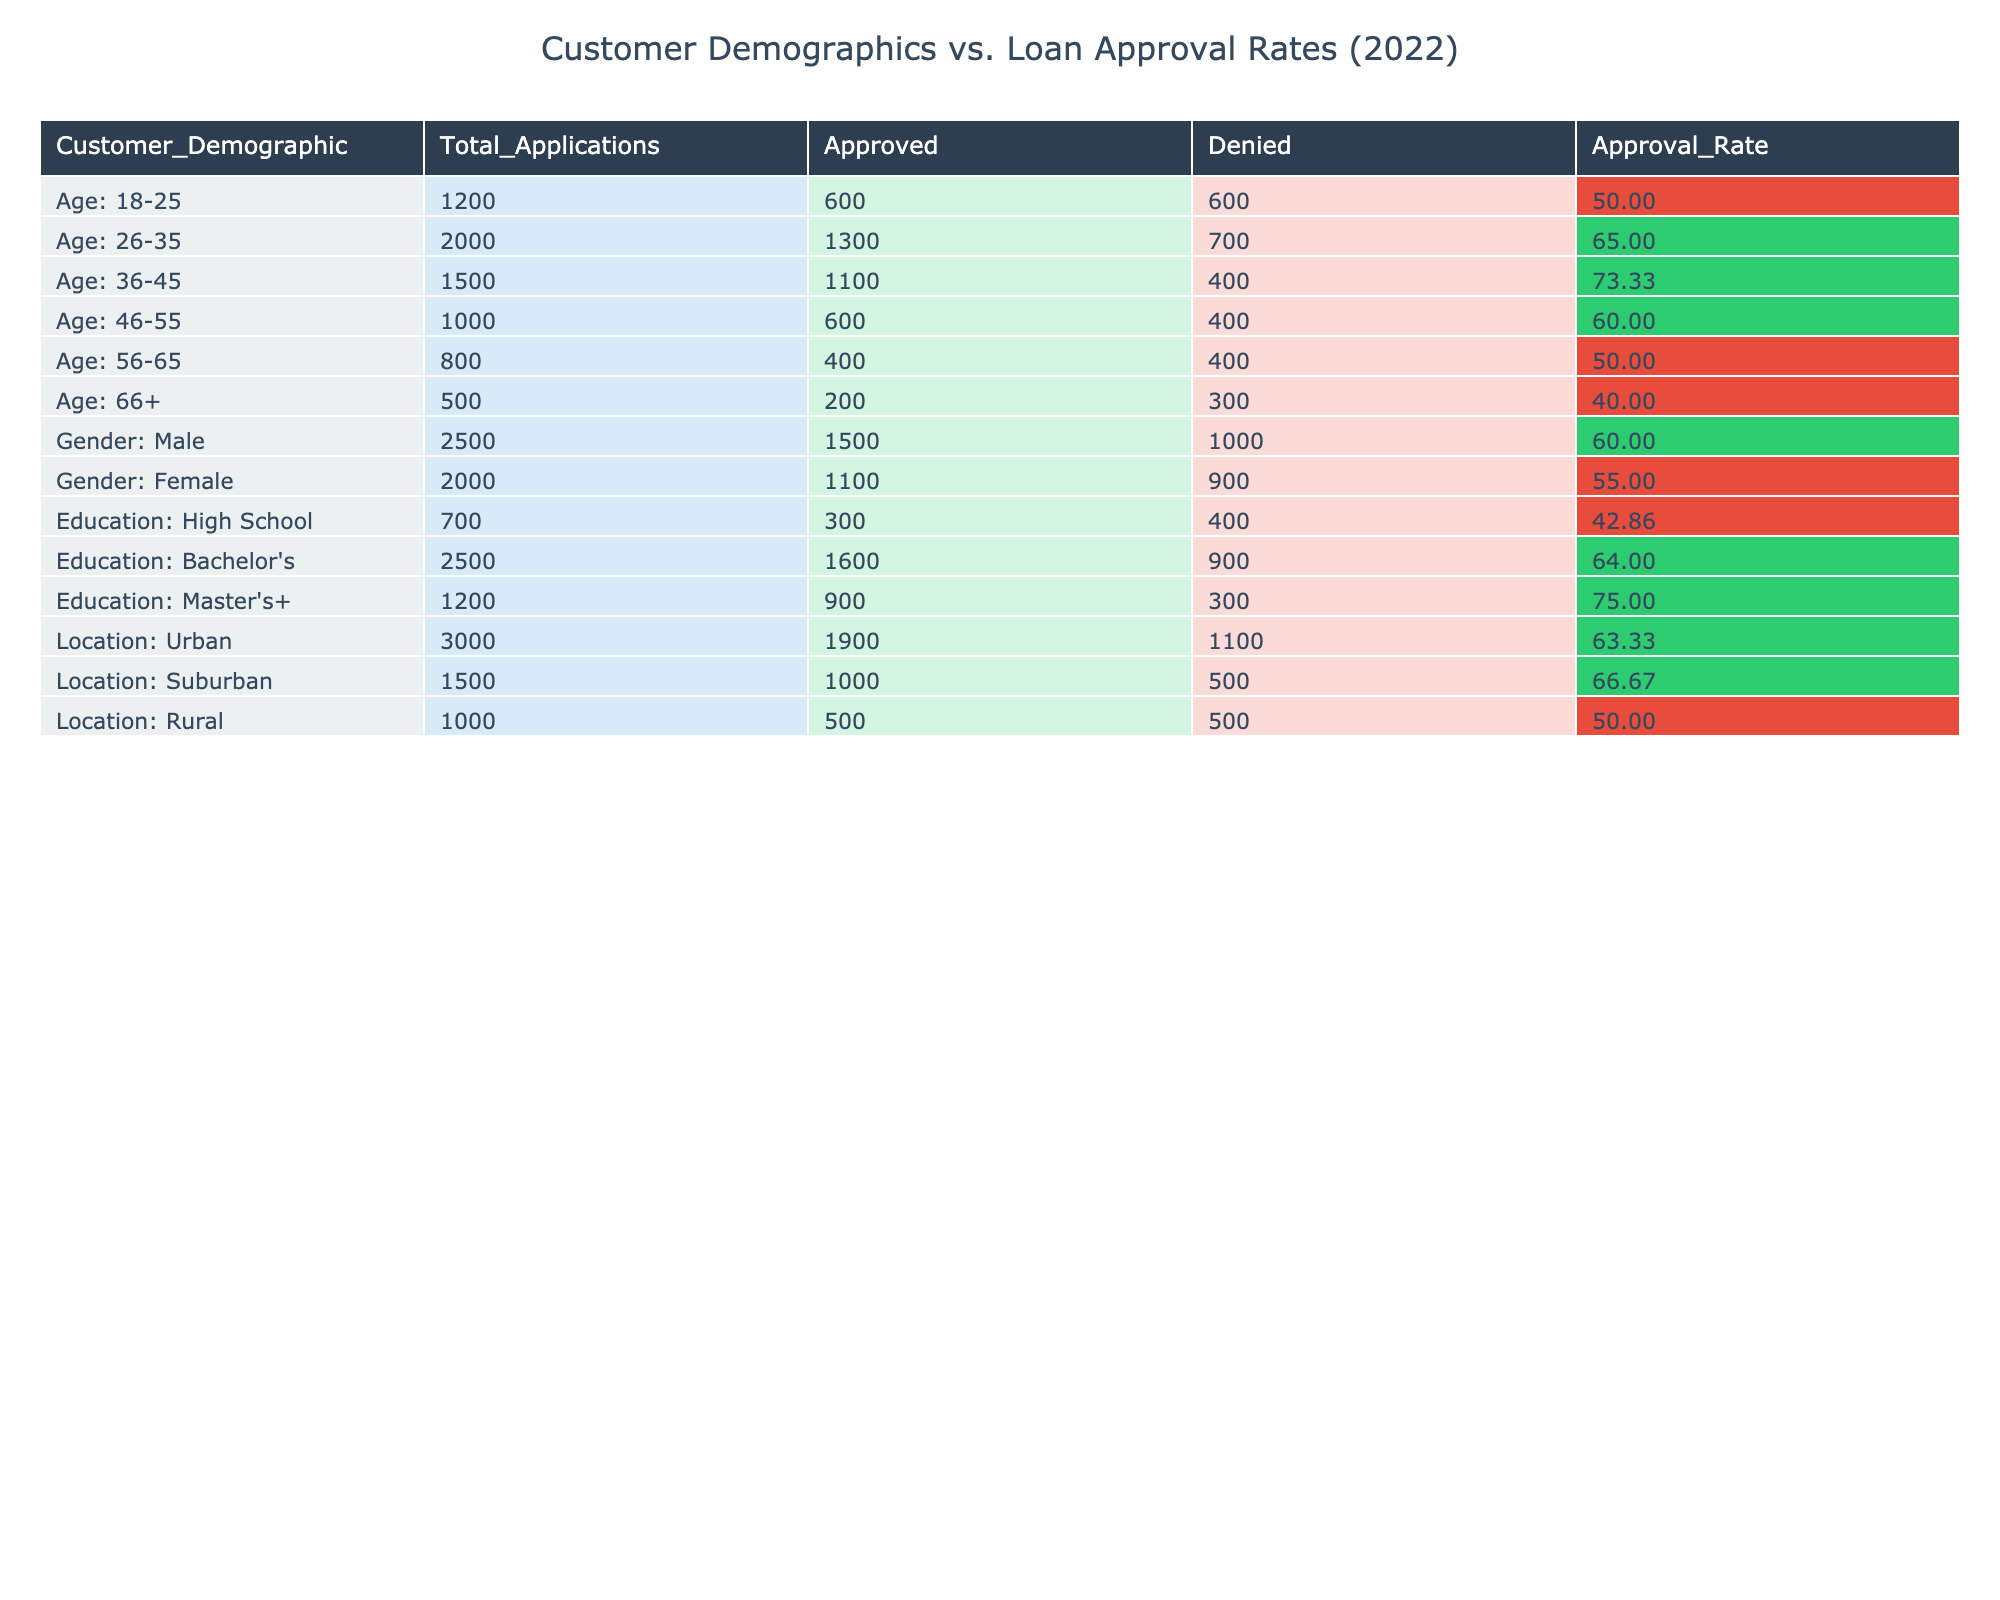What is the approval rate for customers aged 36-45? The approval rate for customers in this age group is stated directly in the table under the "Approval_Rate" column for "Age: 36-45." It shows 73.33%.
Answer: 73.33% Which demographic group has the highest total applications? The total applications for each demographic group are listed in the "Total_Applications" column. By comparing the numbers, "Location: Urban" has the highest total applications at 3000.
Answer: Location: Urban What is the difference in approval rates between Bachelor's degree holders and Master's+ degree holders? The approval rate for "Education: Bachelor's" is 64.00% and for "Education: Master's+" is 75.00%. To find the difference, subtract 64.00% from 75.00%, which equals 11.00%.
Answer: 11.00% Is the approval rate for females higher than for customers aged 66 and above? The approval rate for "Gender: Female" is 55.00%, while for "Age: 66+" it is 40.00%. Since 55.00% is greater than 40.00%, the statement is true.
Answer: Yes What is the average approval rate for customers in rural areas compared to urban customers? The average approval rate for "Location: Rural" is 50.00% and for "Location: Urban" is 63.33%. To compare, the average for urban customers is higher, indicating a difference of 13.33%.
Answer: 13.33% (Urban higher) Which age group has the lowest approval rate? By looking through the "Approval_Rate" column, the lowest approval rate is for customers aged 66 and above at 40.00%.
Answer: Age: 66+ If we combine the approval rates of all female applicants and male applicants, which group is more favorable? The approval rate for "Gender: Male" is 60.00%, whereas for "Gender: Female" it is 55.00%. Since 60.00% is greater than 55.00%, male applicants are more favorable.
Answer: Male applicants How many applications were denied for the demographic group with the highest approval rate? The demographic group with the highest rate is "Education: Master's+". It had 300 denials according to the "Denied" column.
Answer: 300 